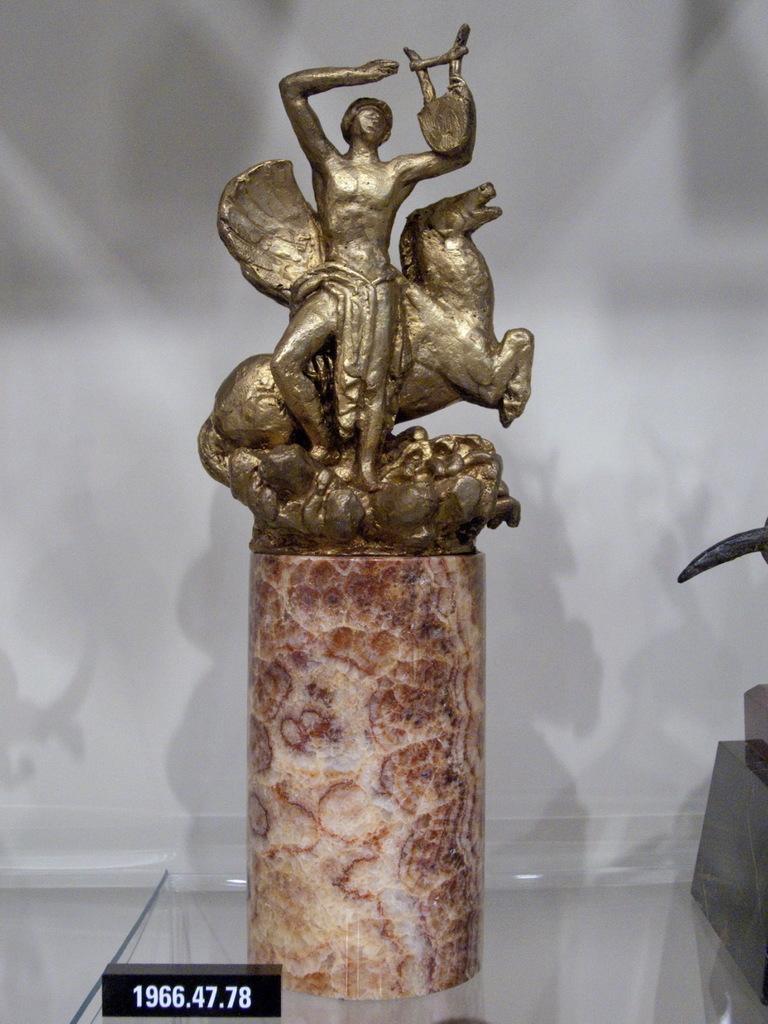Describe this image in one or two sentences. In this image I can see a sculpture and on the bottom left side of the image I can see something is written on the black colour thing. I can also see an object on the right side of the image. 